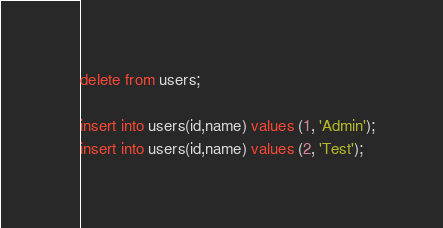<code> <loc_0><loc_0><loc_500><loc_500><_SQL_>delete from users;

insert into users(id,name) values (1, 'Admin');
insert into users(id,name) values (2, 'Test');
</code> 